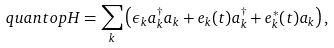<formula> <loc_0><loc_0><loc_500><loc_500>\ q u a n t o p { H } = \sum _ { k } \left ( \epsilon _ { k } a ^ { \dagger } _ { k } a _ { k } + e _ { k } ( t ) a ^ { \dagger } _ { k } + e _ { k } ^ { * } ( t ) a _ { k } \right ) ,</formula> 